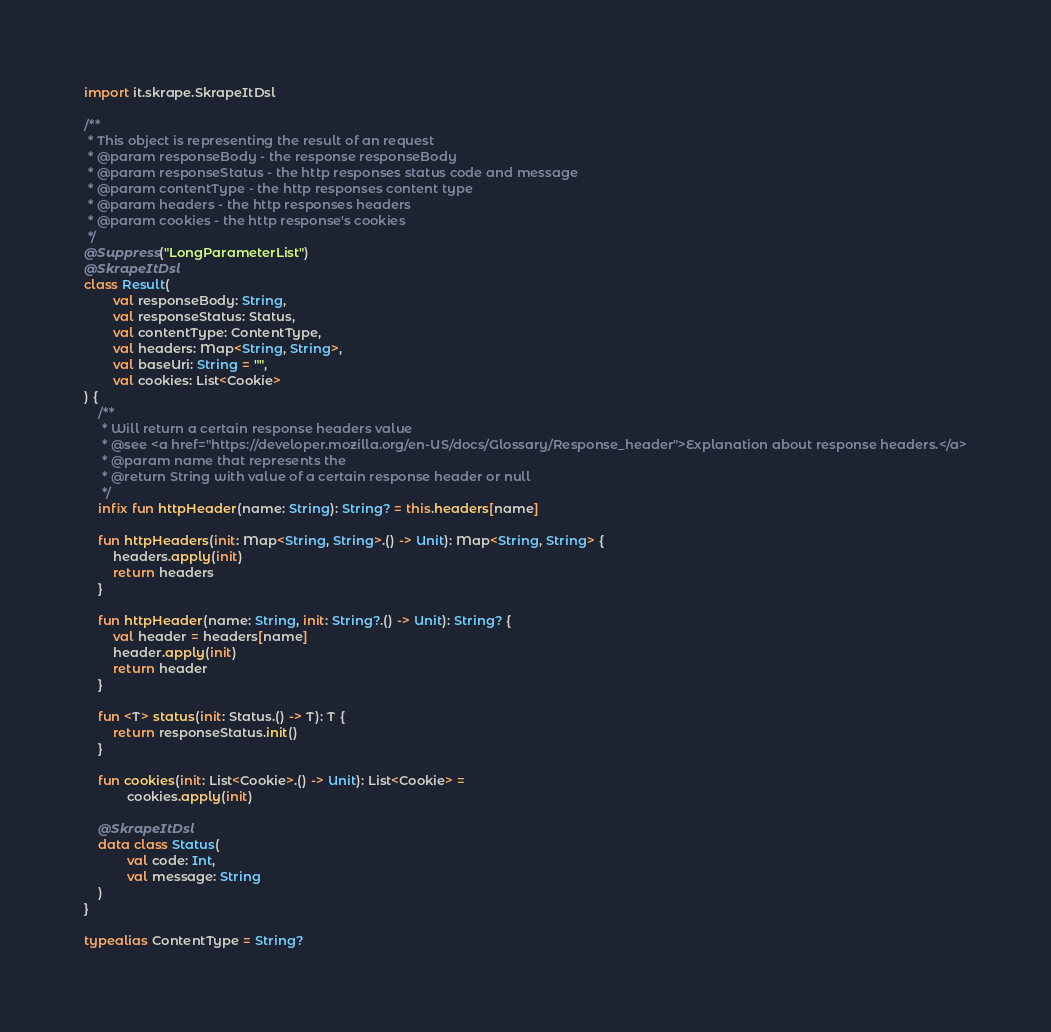<code> <loc_0><loc_0><loc_500><loc_500><_Kotlin_>
import it.skrape.SkrapeItDsl

/**
 * This object is representing the result of an request
 * @param responseBody - the response responseBody
 * @param responseStatus - the http responses status code and message
 * @param contentType - the http responses content type
 * @param headers - the http responses headers
 * @param cookies - the http response's cookies
 */
@Suppress("LongParameterList")
@SkrapeItDsl
class Result(
        val responseBody: String,
        val responseStatus: Status,
        val contentType: ContentType,
        val headers: Map<String, String>,
        val baseUri: String = "",
        val cookies: List<Cookie>
) {
    /**
     * Will return a certain response headers value
     * @see <a href="https://developer.mozilla.org/en-US/docs/Glossary/Response_header">Explanation about response headers.</a>
     * @param name that represents the
     * @return String with value of a certain response header or null
     */
    infix fun httpHeader(name: String): String? = this.headers[name]

    fun httpHeaders(init: Map<String, String>.() -> Unit): Map<String, String> {
        headers.apply(init)
        return headers
    }

    fun httpHeader(name: String, init: String?.() -> Unit): String? {
        val header = headers[name]
        header.apply(init)
        return header
    }

    fun <T> status(init: Status.() -> T): T {
        return responseStatus.init()
    }

    fun cookies(init: List<Cookie>.() -> Unit): List<Cookie> =
            cookies.apply(init)

    @SkrapeItDsl
    data class Status(
            val code: Int,
            val message: String
    )
}

typealias ContentType = String?
</code> 